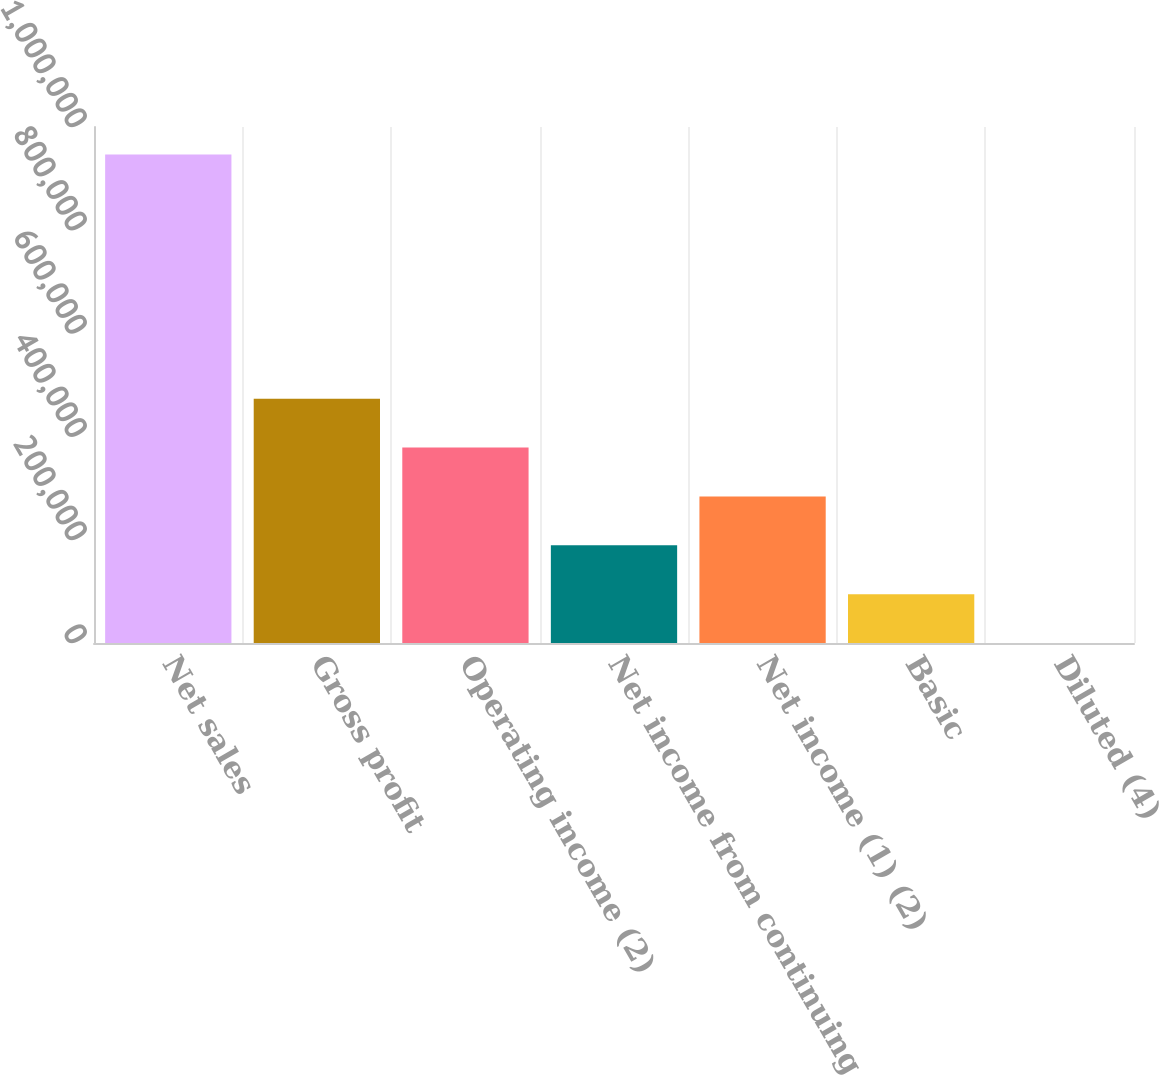Convert chart. <chart><loc_0><loc_0><loc_500><loc_500><bar_chart><fcel>Net sales<fcel>Gross profit<fcel>Operating income (2)<fcel>Net income from continuing<fcel>Net income (1) (2)<fcel>Basic<fcel>Diluted (4)<nl><fcel>946924<fcel>473462<fcel>378770<fcel>189385<fcel>284078<fcel>94693.1<fcel>0.79<nl></chart> 